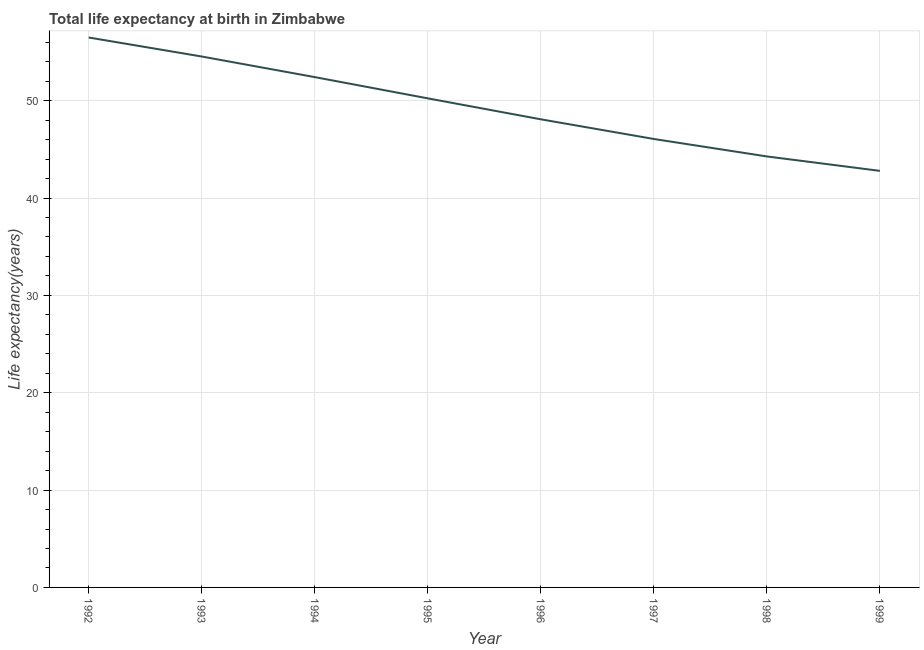What is the life expectancy at birth in 1994?
Provide a short and direct response. 52.42. Across all years, what is the maximum life expectancy at birth?
Your answer should be compact. 56.49. Across all years, what is the minimum life expectancy at birth?
Provide a succinct answer. 42.79. In which year was the life expectancy at birth minimum?
Provide a short and direct response. 1999. What is the sum of the life expectancy at birth?
Your answer should be very brief. 394.91. What is the difference between the life expectancy at birth in 1996 and 1999?
Provide a succinct answer. 5.3. What is the average life expectancy at birth per year?
Provide a short and direct response. 49.36. What is the median life expectancy at birth?
Keep it short and to the point. 49.16. What is the ratio of the life expectancy at birth in 1993 to that in 1997?
Your response must be concise. 1.18. What is the difference between the highest and the second highest life expectancy at birth?
Offer a terse response. 1.95. What is the difference between the highest and the lowest life expectancy at birth?
Offer a very short reply. 13.7. Does the life expectancy at birth monotonically increase over the years?
Provide a succinct answer. No. How many lines are there?
Ensure brevity in your answer.  1. What is the difference between two consecutive major ticks on the Y-axis?
Offer a terse response. 10. Are the values on the major ticks of Y-axis written in scientific E-notation?
Provide a short and direct response. No. What is the title of the graph?
Your response must be concise. Total life expectancy at birth in Zimbabwe. What is the label or title of the X-axis?
Your answer should be compact. Year. What is the label or title of the Y-axis?
Your response must be concise. Life expectancy(years). What is the Life expectancy(years) of 1992?
Provide a short and direct response. 56.49. What is the Life expectancy(years) of 1993?
Your response must be concise. 54.54. What is the Life expectancy(years) in 1994?
Provide a short and direct response. 52.42. What is the Life expectancy(years) in 1995?
Your answer should be compact. 50.24. What is the Life expectancy(years) of 1996?
Keep it short and to the point. 48.09. What is the Life expectancy(years) in 1997?
Offer a very short reply. 46.07. What is the Life expectancy(years) in 1998?
Give a very brief answer. 44.27. What is the Life expectancy(years) of 1999?
Ensure brevity in your answer.  42.79. What is the difference between the Life expectancy(years) in 1992 and 1993?
Offer a very short reply. 1.95. What is the difference between the Life expectancy(years) in 1992 and 1994?
Your answer should be very brief. 4.07. What is the difference between the Life expectancy(years) in 1992 and 1995?
Provide a succinct answer. 6.25. What is the difference between the Life expectancy(years) in 1992 and 1996?
Offer a very short reply. 8.4. What is the difference between the Life expectancy(years) in 1992 and 1997?
Your answer should be compact. 10.43. What is the difference between the Life expectancy(years) in 1992 and 1998?
Offer a terse response. 12.22. What is the difference between the Life expectancy(years) in 1992 and 1999?
Keep it short and to the point. 13.7. What is the difference between the Life expectancy(years) in 1993 and 1994?
Provide a short and direct response. 2.12. What is the difference between the Life expectancy(years) in 1993 and 1995?
Your answer should be very brief. 4.3. What is the difference between the Life expectancy(years) in 1993 and 1996?
Ensure brevity in your answer.  6.45. What is the difference between the Life expectancy(years) in 1993 and 1997?
Keep it short and to the point. 8.47. What is the difference between the Life expectancy(years) in 1993 and 1998?
Ensure brevity in your answer.  10.27. What is the difference between the Life expectancy(years) in 1993 and 1999?
Ensure brevity in your answer.  11.75. What is the difference between the Life expectancy(years) in 1994 and 1995?
Offer a terse response. 2.18. What is the difference between the Life expectancy(years) in 1994 and 1996?
Your answer should be very brief. 4.33. What is the difference between the Life expectancy(years) in 1994 and 1997?
Give a very brief answer. 6.36. What is the difference between the Life expectancy(years) in 1994 and 1998?
Make the answer very short. 8.15. What is the difference between the Life expectancy(years) in 1994 and 1999?
Provide a succinct answer. 9.63. What is the difference between the Life expectancy(years) in 1995 and 1996?
Give a very brief answer. 2.15. What is the difference between the Life expectancy(years) in 1995 and 1997?
Make the answer very short. 4.17. What is the difference between the Life expectancy(years) in 1995 and 1998?
Offer a very short reply. 5.97. What is the difference between the Life expectancy(years) in 1995 and 1999?
Keep it short and to the point. 7.45. What is the difference between the Life expectancy(years) in 1996 and 1997?
Provide a short and direct response. 2.02. What is the difference between the Life expectancy(years) in 1996 and 1998?
Offer a very short reply. 3.82. What is the difference between the Life expectancy(years) in 1996 and 1999?
Your answer should be very brief. 5.3. What is the difference between the Life expectancy(years) in 1997 and 1998?
Give a very brief answer. 1.79. What is the difference between the Life expectancy(years) in 1997 and 1999?
Your answer should be compact. 3.27. What is the difference between the Life expectancy(years) in 1998 and 1999?
Provide a succinct answer. 1.48. What is the ratio of the Life expectancy(years) in 1992 to that in 1993?
Keep it short and to the point. 1.04. What is the ratio of the Life expectancy(years) in 1992 to that in 1994?
Make the answer very short. 1.08. What is the ratio of the Life expectancy(years) in 1992 to that in 1995?
Your response must be concise. 1.12. What is the ratio of the Life expectancy(years) in 1992 to that in 1996?
Your response must be concise. 1.18. What is the ratio of the Life expectancy(years) in 1992 to that in 1997?
Provide a succinct answer. 1.23. What is the ratio of the Life expectancy(years) in 1992 to that in 1998?
Your answer should be very brief. 1.28. What is the ratio of the Life expectancy(years) in 1992 to that in 1999?
Provide a short and direct response. 1.32. What is the ratio of the Life expectancy(years) in 1993 to that in 1994?
Your response must be concise. 1.04. What is the ratio of the Life expectancy(years) in 1993 to that in 1995?
Give a very brief answer. 1.09. What is the ratio of the Life expectancy(years) in 1993 to that in 1996?
Provide a succinct answer. 1.13. What is the ratio of the Life expectancy(years) in 1993 to that in 1997?
Ensure brevity in your answer.  1.18. What is the ratio of the Life expectancy(years) in 1993 to that in 1998?
Your answer should be very brief. 1.23. What is the ratio of the Life expectancy(years) in 1993 to that in 1999?
Give a very brief answer. 1.27. What is the ratio of the Life expectancy(years) in 1994 to that in 1995?
Your response must be concise. 1.04. What is the ratio of the Life expectancy(years) in 1994 to that in 1996?
Your answer should be very brief. 1.09. What is the ratio of the Life expectancy(years) in 1994 to that in 1997?
Your response must be concise. 1.14. What is the ratio of the Life expectancy(years) in 1994 to that in 1998?
Offer a terse response. 1.18. What is the ratio of the Life expectancy(years) in 1994 to that in 1999?
Give a very brief answer. 1.23. What is the ratio of the Life expectancy(years) in 1995 to that in 1996?
Offer a very short reply. 1.04. What is the ratio of the Life expectancy(years) in 1995 to that in 1997?
Offer a terse response. 1.09. What is the ratio of the Life expectancy(years) in 1995 to that in 1998?
Offer a terse response. 1.14. What is the ratio of the Life expectancy(years) in 1995 to that in 1999?
Your response must be concise. 1.17. What is the ratio of the Life expectancy(years) in 1996 to that in 1997?
Make the answer very short. 1.04. What is the ratio of the Life expectancy(years) in 1996 to that in 1998?
Provide a short and direct response. 1.09. What is the ratio of the Life expectancy(years) in 1996 to that in 1999?
Give a very brief answer. 1.12. What is the ratio of the Life expectancy(years) in 1997 to that in 1998?
Your response must be concise. 1.04. What is the ratio of the Life expectancy(years) in 1997 to that in 1999?
Ensure brevity in your answer.  1.08. What is the ratio of the Life expectancy(years) in 1998 to that in 1999?
Give a very brief answer. 1.03. 